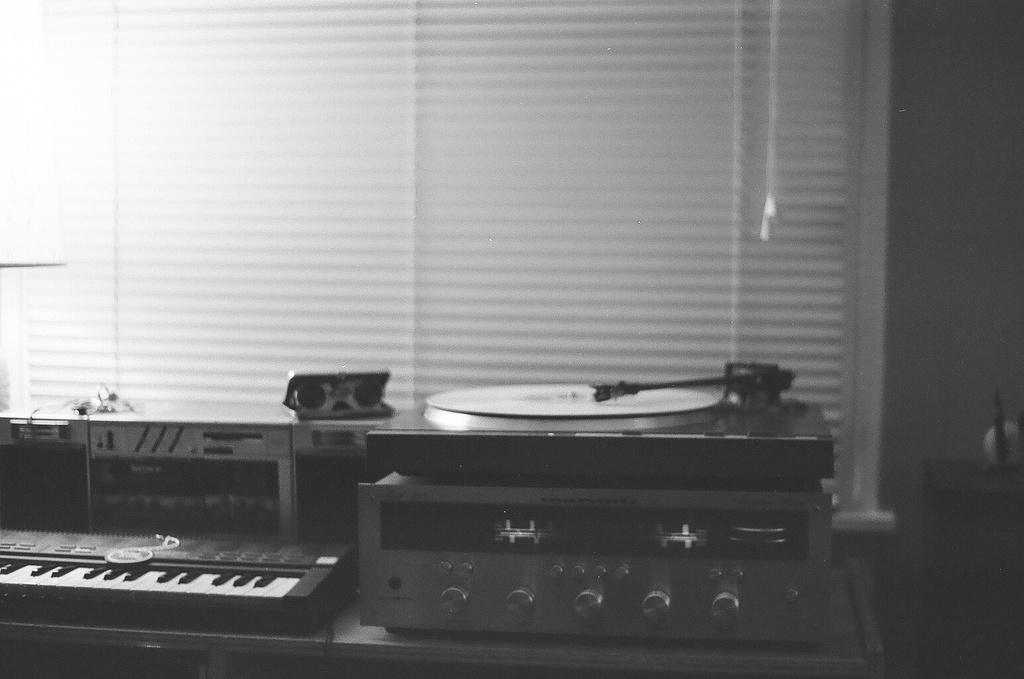What type of musical instrument is in the image? There is a piano in the image. What other musical equipment can be seen in the image? There is musical equipment in the image, but it is not specified what kind. What device is used for playing CDs in the image? There is a CD player in the image. What can be seen in the background of the image? There is a wall and a window in the background of the image. What type of wool is being offered in the image? There is no wool present in the image; it features related to music and background elements. 